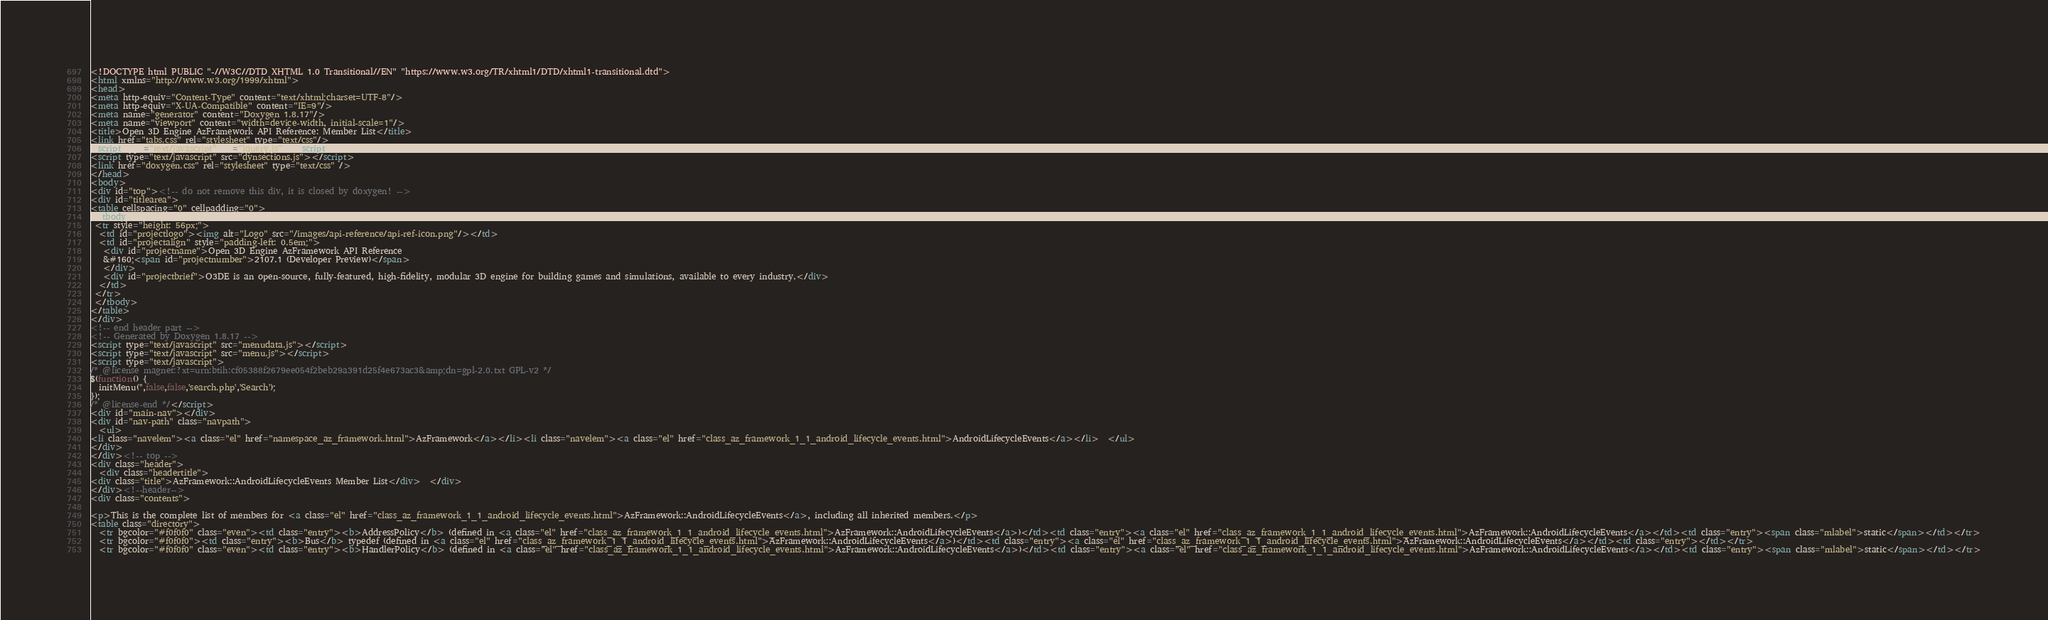Convert code to text. <code><loc_0><loc_0><loc_500><loc_500><_HTML_><!DOCTYPE html PUBLIC "-//W3C//DTD XHTML 1.0 Transitional//EN" "https://www.w3.org/TR/xhtml1/DTD/xhtml1-transitional.dtd">
<html xmlns="http://www.w3.org/1999/xhtml">
<head>
<meta http-equiv="Content-Type" content="text/xhtml;charset=UTF-8"/>
<meta http-equiv="X-UA-Compatible" content="IE=9"/>
<meta name="generator" content="Doxygen 1.8.17"/>
<meta name="viewport" content="width=device-width, initial-scale=1"/>
<title>Open 3D Engine AzFramework API Reference: Member List</title>
<link href="tabs.css" rel="stylesheet" type="text/css"/>
<script type="text/javascript" src="jquery.js"></script>
<script type="text/javascript" src="dynsections.js"></script>
<link href="doxygen.css" rel="stylesheet" type="text/css" />
</head>
<body>
<div id="top"><!-- do not remove this div, it is closed by doxygen! -->
<div id="titlearea">
<table cellspacing="0" cellpadding="0">
 <tbody>
 <tr style="height: 56px;">
  <td id="projectlogo"><img alt="Logo" src="/images/api-reference/api-ref-icon.png"/></td>
  <td id="projectalign" style="padding-left: 0.5em;">
   <div id="projectname">Open 3D Engine AzFramework API Reference
   &#160;<span id="projectnumber">2107.1 (Developer Preview)</span>
   </div>
   <div id="projectbrief">O3DE is an open-source, fully-featured, high-fidelity, modular 3D engine for building games and simulations, available to every industry.</div>
  </td>
 </tr>
 </tbody>
</table>
</div>
<!-- end header part -->
<!-- Generated by Doxygen 1.8.17 -->
<script type="text/javascript" src="menudata.js"></script>
<script type="text/javascript" src="menu.js"></script>
<script type="text/javascript">
/* @license magnet:?xt=urn:btih:cf05388f2679ee054f2beb29a391d25f4e673ac3&amp;dn=gpl-2.0.txt GPL-v2 */
$(function() {
  initMenu('',false,false,'search.php','Search');
});
/* @license-end */</script>
<div id="main-nav"></div>
<div id="nav-path" class="navpath">
  <ul>
<li class="navelem"><a class="el" href="namespace_az_framework.html">AzFramework</a></li><li class="navelem"><a class="el" href="class_az_framework_1_1_android_lifecycle_events.html">AndroidLifecycleEvents</a></li>  </ul>
</div>
</div><!-- top -->
<div class="header">
  <div class="headertitle">
<div class="title">AzFramework::AndroidLifecycleEvents Member List</div>  </div>
</div><!--header-->
<div class="contents">

<p>This is the complete list of members for <a class="el" href="class_az_framework_1_1_android_lifecycle_events.html">AzFramework::AndroidLifecycleEvents</a>, including all inherited members.</p>
<table class="directory">
  <tr bgcolor="#f0f0f0" class="even"><td class="entry"><b>AddressPolicy</b> (defined in <a class="el" href="class_az_framework_1_1_android_lifecycle_events.html">AzFramework::AndroidLifecycleEvents</a>)</td><td class="entry"><a class="el" href="class_az_framework_1_1_android_lifecycle_events.html">AzFramework::AndroidLifecycleEvents</a></td><td class="entry"><span class="mlabel">static</span></td></tr>
  <tr bgcolor="#f0f0f0"><td class="entry"><b>Bus</b> typedef (defined in <a class="el" href="class_az_framework_1_1_android_lifecycle_events.html">AzFramework::AndroidLifecycleEvents</a>)</td><td class="entry"><a class="el" href="class_az_framework_1_1_android_lifecycle_events.html">AzFramework::AndroidLifecycleEvents</a></td><td class="entry"></td></tr>
  <tr bgcolor="#f0f0f0" class="even"><td class="entry"><b>HandlerPolicy</b> (defined in <a class="el" href="class_az_framework_1_1_android_lifecycle_events.html">AzFramework::AndroidLifecycleEvents</a>)</td><td class="entry"><a class="el" href="class_az_framework_1_1_android_lifecycle_events.html">AzFramework::AndroidLifecycleEvents</a></td><td class="entry"><span class="mlabel">static</span></td></tr></code> 